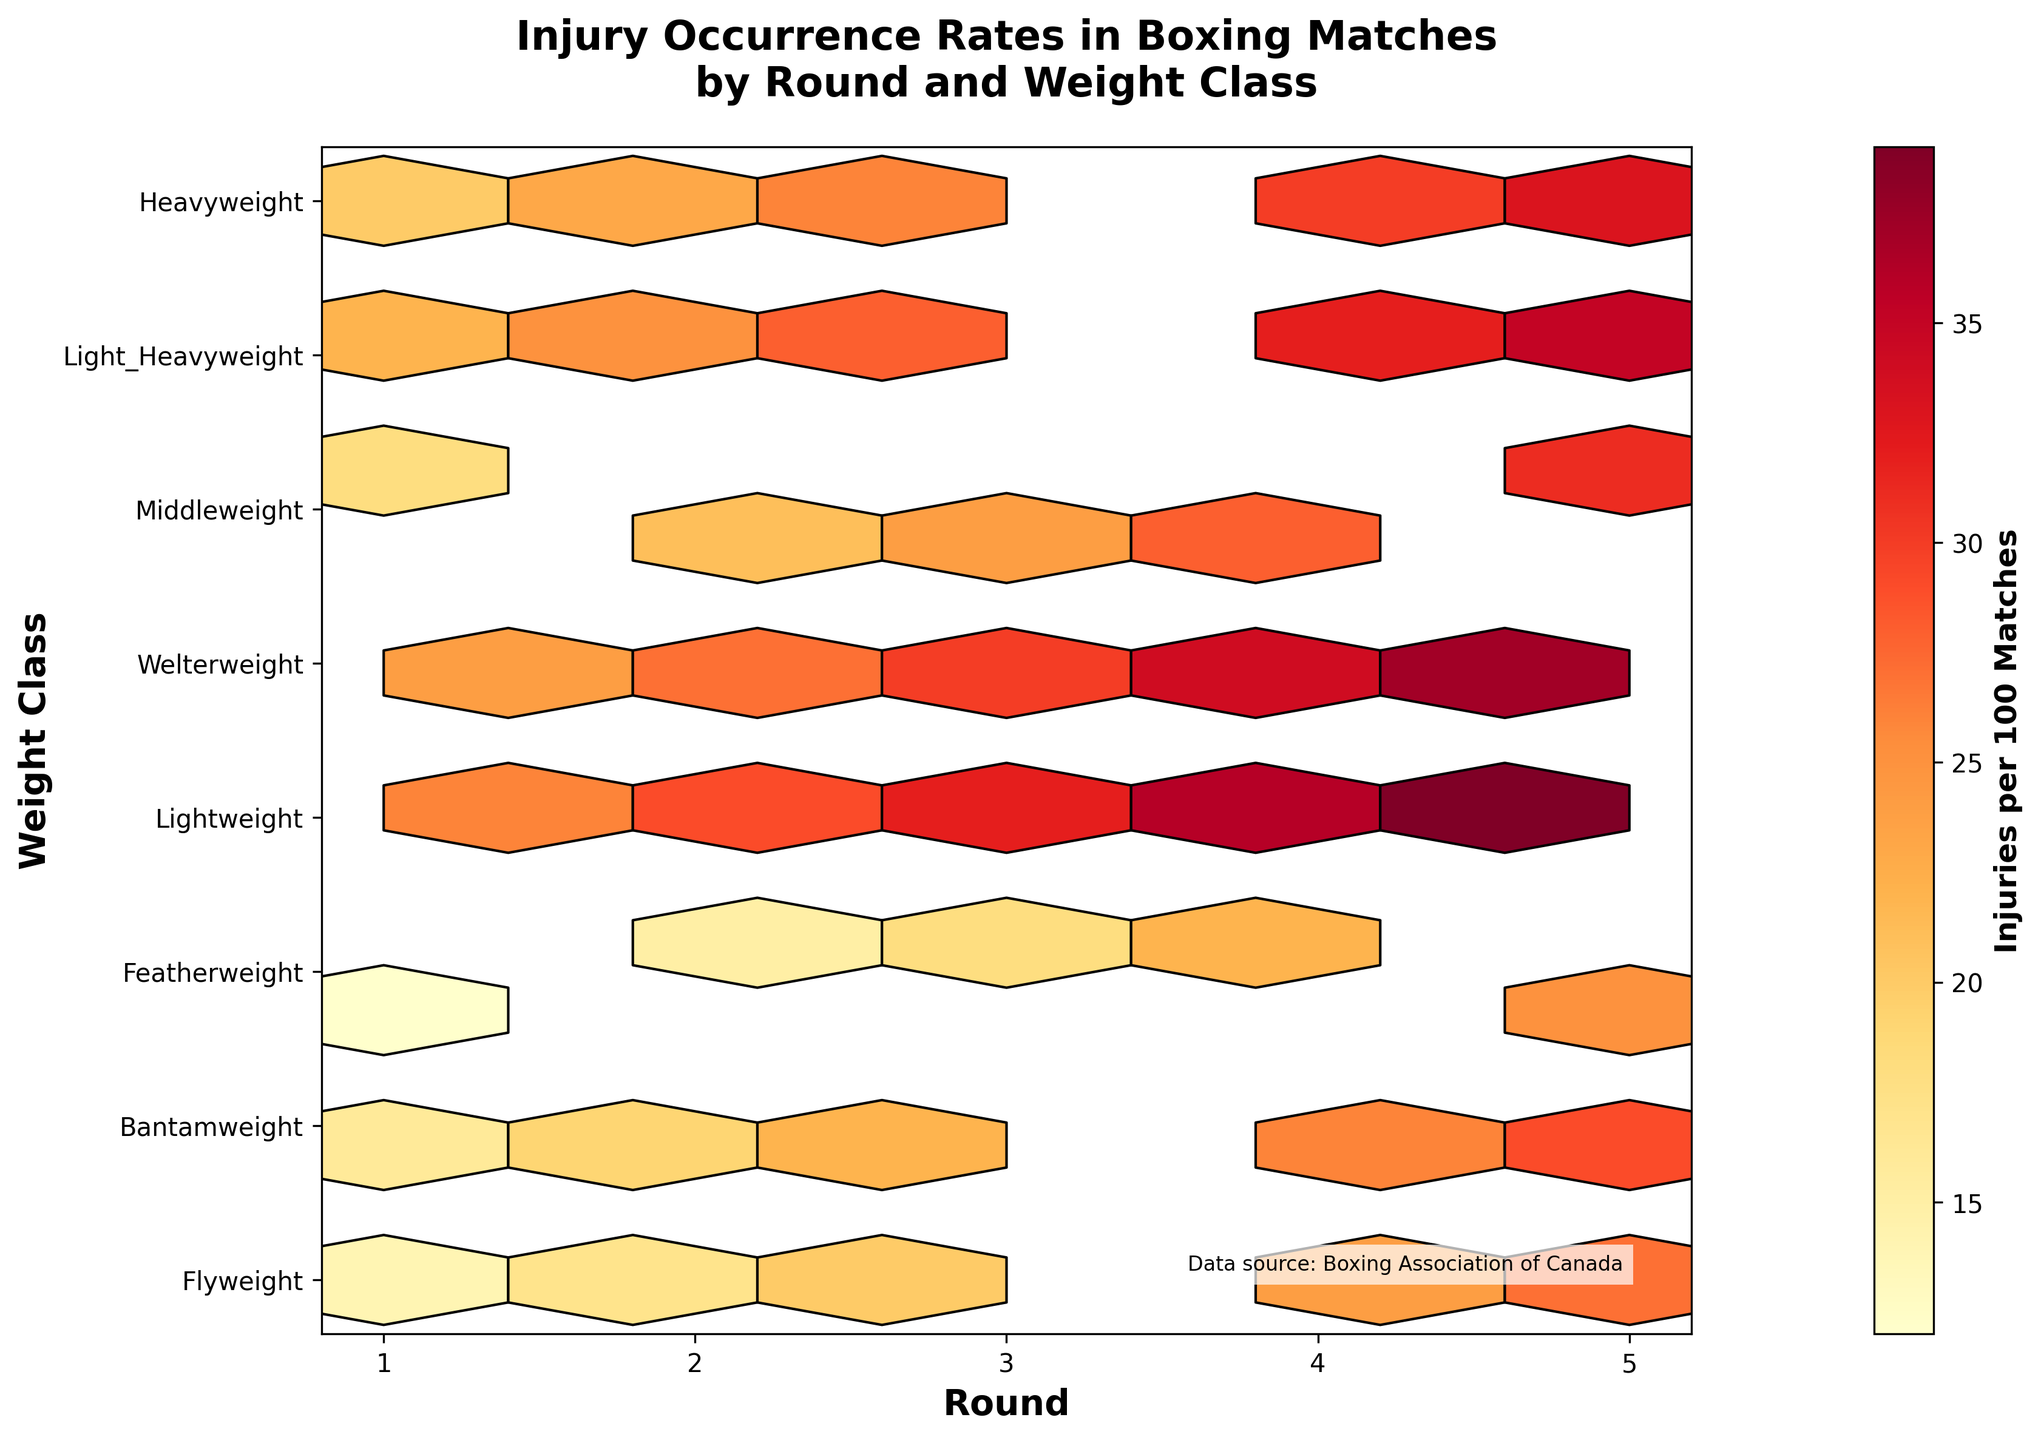What is the range of the colorbar? The colorbar ranges from the minimum to the maximum value of injuries per 100 matches across all weight classes and rounds. By reading the colorbar, we see it starts at "12" and ends at "39".
Answer: 12 to 39 What are the axes labels on the plot? The x-axis is labeled "Round" and the y-axis is labeled "Weight Class". The x-axis has tick marks from 1 to 5 for the five rounds, and the y-axis lists various weight classes.
Answer: Round and Weight Class Which weight class has the highest injury occurrence rate in round 5? To find the weight class with the highest injury rate in round 5, locate the column for round 5 and identify the highest value. The highest injury rate in round 5 is in the Heavyweight class with 39 injuries per 100 matches.
Answer: Heavyweight How does the injury rate change from round 1 to round 5 in the Featherweight class? Analyze the row corresponding to the Featherweight class from round 1 to round 5: 16, 19, 22, 26, 29. The injury rate increases progressively from 16 to 29 injuries per 100 matches.
Answer: Increases progressively Which round has the overall highest injury rates across all weight classes? By comparing the color intensity across the rounds, we see that round 5 consistently shows higher values across all weight classes. Since Heavyweight in round 5 has the highest recorded value of 39, round 5 has the overall highest injury rates.
Answer: Round 5 What is the total number of injuries per 100 matches in the Flyweight class across all rounds? Sum the values for the Flyweight class across all rounds: 12 (round 1) + 15 (round 2) + 18 (round 3) + 22 (round 4) + 25 (round 5) = 92 injuries per 100 matches.
Answer: 92 Is there a weight class where injury rates decrease from one round to the next? Check if any weight class has decreasing values, but all weight classes show increasing injury rates from round 1 to round 5. No instances of decrease are observed.
Answer: No Which round has the smallest increase in injuries from the previous round in the Welterweight class? Subtract the number of injuries in each round from the subsequent round for Welterweight: 
Round 1 to 2: 23 - 20 = 3,
Round 2 to 3: 26 - 23 = 3,
Round 3 to 4: 30 - 26 = 4,
Round 4 to 5: 33 - 30 = 3.
The smallest increase is observed between rounds 1 to 2, 2 to 3, and 4 to 5 which are all 3.
Answer: Rounds 1 to 2, 2 to 3, and 4 to 5 Which weight class shows the fastest rate of increase in injuries per 100 matches? Calculate the difference for each weight class between round 1 and round 5, and find the highest difference.
Flyweight: 25-12 = 13,
Bantamweight: 27-14 = 13,
Featherweight: 29-16 = 13,
Lightweight: 31-18 = 13,
Welterweight: 33-20 = 13,
Middleweight: 35-22 = 13,
Light Heavyweight: 37-24 = 13,
Heavyweight: 39-26 = 13.
All weight classes have an equal increase of 13 injuries per 100 matches from round 1 to round 5.
Answer: All, equally 